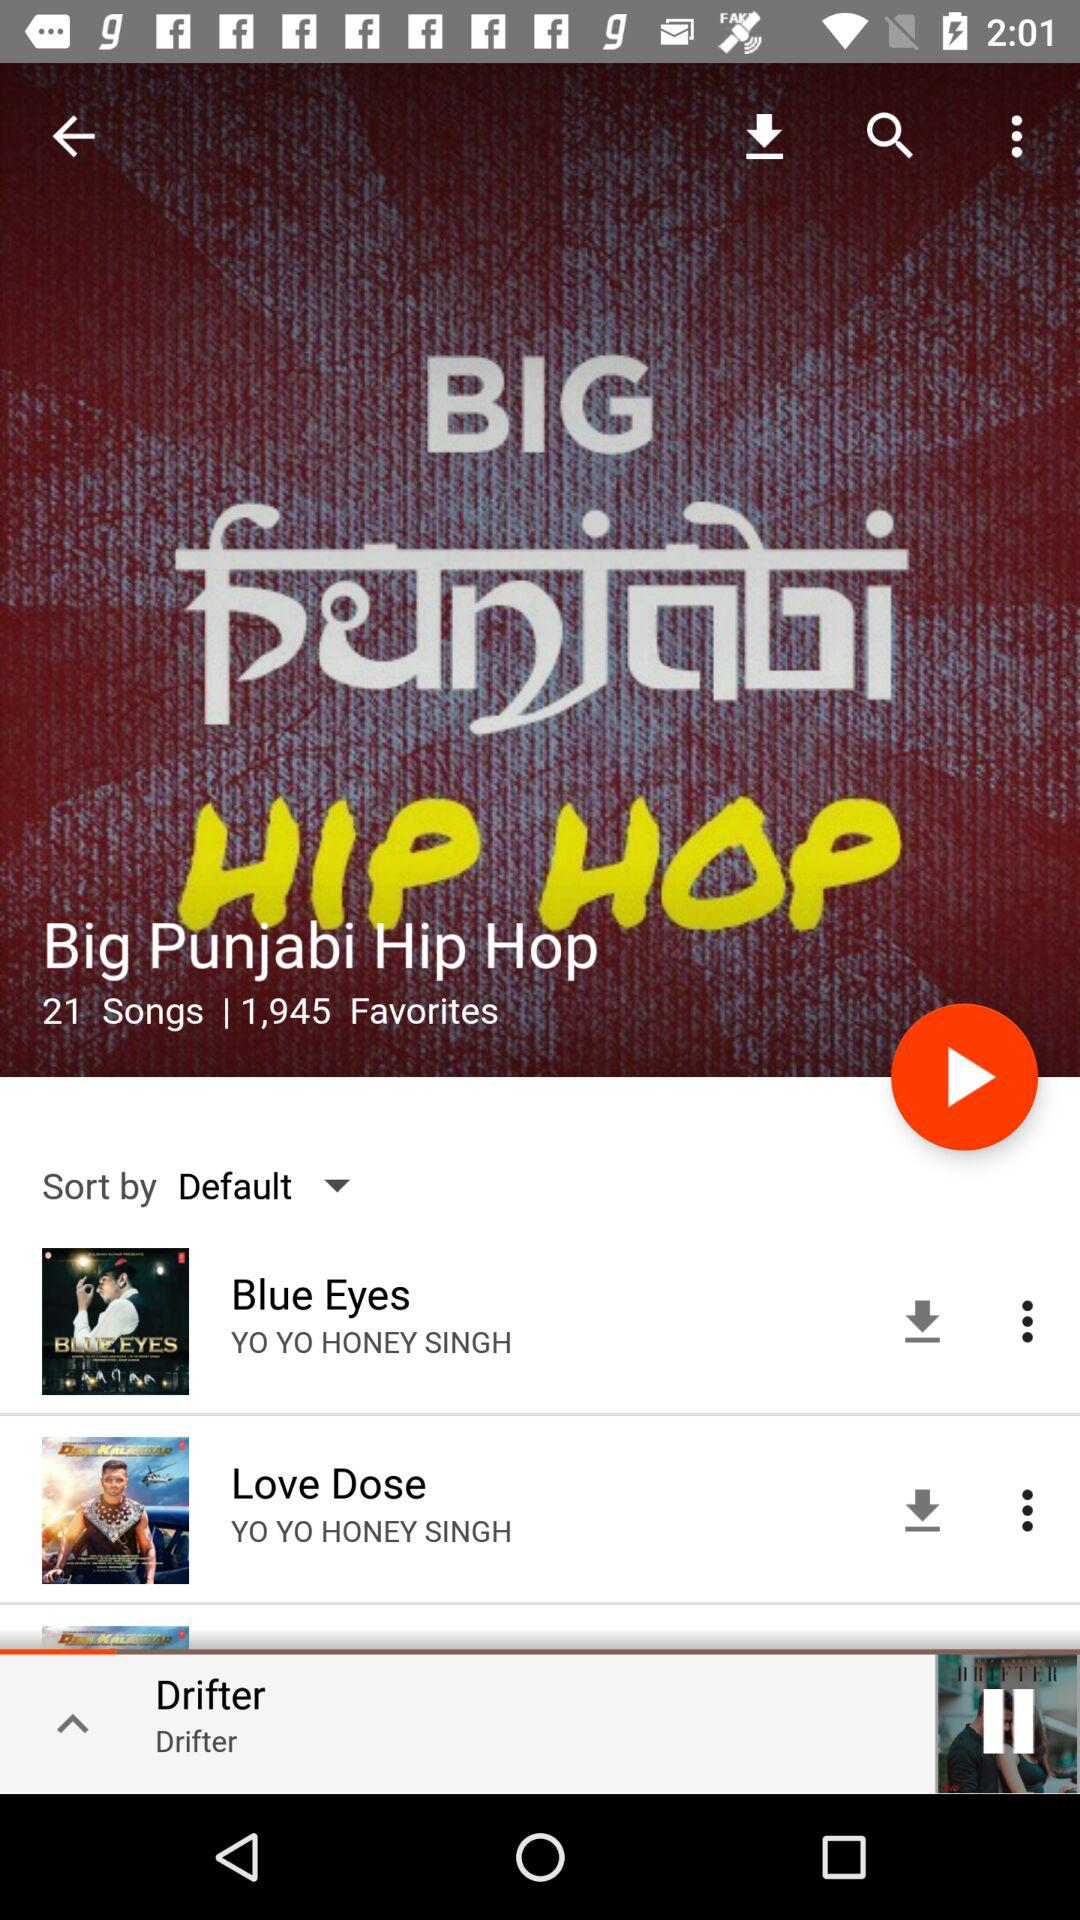How many songs are in the Big Punjabi Hip Hop category?
Answer the question using a single word or phrase. 21 